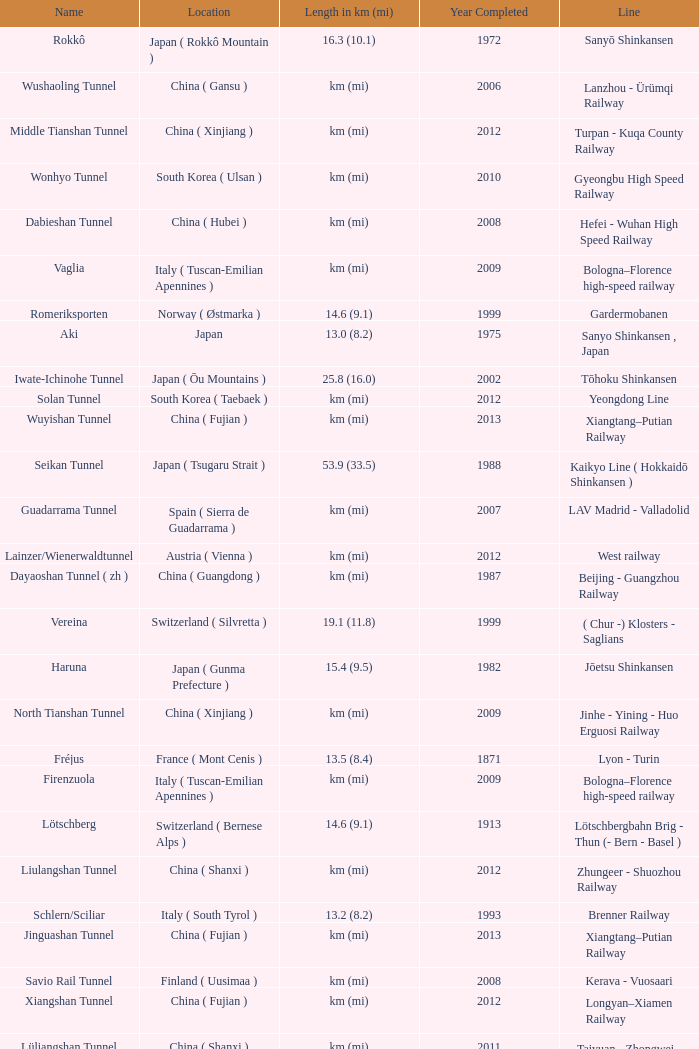Give me the full table as a dictionary. {'header': ['Name', 'Location', 'Length in km (mi)', 'Year Completed', 'Line'], 'rows': [['Rokkô', 'Japan ( Rokkô Mountain )', '16.3 (10.1)', '1972', 'Sanyō Shinkansen'], ['Wushaoling Tunnel', 'China ( Gansu )', 'km (mi)', '2006', 'Lanzhou - Ürümqi Railway'], ['Middle Tianshan Tunnel', 'China ( Xinjiang )', 'km (mi)', '2012', 'Turpan - Kuqa County Railway'], ['Wonhyo Tunnel', 'South Korea ( Ulsan )', 'km (mi)', '2010', 'Gyeongbu High Speed Railway'], ['Dabieshan Tunnel', 'China ( Hubei )', 'km (mi)', '2008', 'Hefei - Wuhan High Speed Railway'], ['Vaglia', 'Italy ( Tuscan-Emilian Apennines )', 'km (mi)', '2009', 'Bologna–Florence high-speed railway'], ['Romeriksporten', 'Norway ( Østmarka )', '14.6 (9.1)', '1999', 'Gardermobanen'], ['Aki', 'Japan', '13.0 (8.2)', '1975', 'Sanyo Shinkansen , Japan'], ['Iwate-Ichinohe Tunnel', 'Japan ( Ōu Mountains )', '25.8 (16.0)', '2002', 'Tōhoku Shinkansen'], ['Solan Tunnel', 'South Korea ( Taebaek )', 'km (mi)', '2012', 'Yeongdong Line'], ['Wuyishan Tunnel', 'China ( Fujian )', 'km (mi)', '2013', 'Xiangtang–Putian Railway'], ['Seikan Tunnel', 'Japan ( Tsugaru Strait )', '53.9 (33.5)', '1988', 'Kaikyo Line ( Hokkaidō Shinkansen )'], ['Guadarrama Tunnel', 'Spain ( Sierra de Guadarrama )', 'km (mi)', '2007', 'LAV Madrid - Valladolid'], ['Lainzer/Wienerwaldtunnel', 'Austria ( Vienna )', 'km (mi)', '2012', 'West railway'], ['Dayaoshan Tunnel ( zh )', 'China ( Guangdong )', 'km (mi)', '1987', 'Beijing - Guangzhou Railway'], ['Vereina', 'Switzerland ( Silvretta )', '19.1 (11.8)', '1999', '( Chur -) Klosters - Saglians'], ['Haruna', 'Japan ( Gunma Prefecture )', '15.4 (9.5)', '1982', 'Jōetsu Shinkansen'], ['North Tianshan Tunnel', 'China ( Xinjiang )', 'km (mi)', '2009', 'Jinhe - Yining - Huo Erguosi Railway'], ['Fréjus', 'France ( Mont Cenis )', '13.5 (8.4)', '1871', 'Lyon - Turin'], ['Firenzuola', 'Italy ( Tuscan-Emilian Apennines )', 'km (mi)', '2009', 'Bologna–Florence high-speed railway'], ['Lötschberg', 'Switzerland ( Bernese Alps )', '14.6 (9.1)', '1913', 'Lötschbergbahn Brig - Thun (- Bern - Basel )'], ['Liulangshan Tunnel', 'China ( Shanxi )', 'km (mi)', '2012', 'Zhungeer - Shuozhou Railway'], ['Schlern/Sciliar', 'Italy ( South Tyrol )', '13.2 (8.2)', '1993', 'Brenner Railway'], ['Jinguashan Tunnel', 'China ( Fujian )', 'km (mi)', '2013', 'Xiangtang–Putian Railway'], ['Savio Rail Tunnel', 'Finland ( Uusimaa )', 'km (mi)', '2008', 'Kerava - Vuosaari'], ['Xiangshan Tunnel', 'China ( Fujian )', 'km (mi)', '2012', 'Longyan–Xiamen Railway'], ['Lüliangshan Tunnel', 'China ( Shanxi )', 'km (mi)', '2011', 'Taiyuan - Zhongwei - Yinchuan Railway'], ['Apennine Base Tunnel', 'Italy ( Apennine Mountains )', '18.5 (11.5)', '1934', 'Bologna - Florence'], ['Gorigamine', 'Japan ( Akaishi Mountains )', '15.2 (9.4)', '1997', 'Nagano Shinkansen ( Hokuriku Shinkansen )'], ['Severomuyskiy', 'Russia ( Severomuysky Range )', '15.3 (9.5)', '2001', 'Baikal Amur Mainline'], ['Xuefengshan Tunnel', 'China ( Fujian )', 'km (mi)', '2013', 'Xiangtang–Putian Railway'], ['Monte Santomarco', 'Italy ( Sila Mountains )', '15.0 (9.3)', '1987', 'Paola - Cosenza'], ['Hakkōda Tunnel', 'Japan ( Hakkōda Mountains )', 'km (mi)', '2010', 'Tōhoku Shinkansen'], ['Qingyunshan Tunnel', 'China ( Fujian )', 'km (mi)', '2013', 'Xiangtang–Putian Railway'], ['Epping to Chatswood RailLink', 'Australia ( Sydney )', '13.5 (8.4)', '2009', 'Epping - Chatswood'], ['Gotthard Rail Tunnel', 'Switzerland ( Lepontine Alps )', '15.0 (9.3)', '1882', 'Gotthardbahn Luzern / Zürich - Lugano - Milano'], ['Daiyunshan Tunnel', 'China ( Fujian )', 'km (mi)', '2013', 'Xiangtang–Putian Railway'], ['Nakayama', 'Japan ( Nakayama Pass )', '14.9 (9.2)', '1982', 'Jōetsu Shinkansen'], ['Gaoganshan Tunnel', 'China ( Fujian )', 'km (mi)', '2013', 'Xiangtang–Putian Railway'], ['Lötschberg Base Tunnel', 'Switzerland ( Bernese Alps )', '34.5 (21.4)', '2007', 'Lötschbergbahn Brig - Thun (- Bern - Basel )'], ['Caponero-Capoverde', 'Italy', '13.1 (8.2)', '2001', 'Genova-Ventimiglia'], ['Simplon (2 tubes)', 'Italy / Switzerland ( Lepontine Alps )', '19.8 (12.3)', '1906/1922', 'Genève/Basel - Brig - Novara / Milano'], ['Daishimizu Tunnel', 'Japan ( Mount Tanigawa )', '22.2 (13.8)', '1982', 'Jōetsu Shinkansen'], ['El Sargento #4', 'Peru', 'km (mi)', '1975', 'Tacna - Moquegua'], ['Hex River', 'South Africa ( Hex River Pass )', 'km (mi)', '1989', 'Pretoria - Cape Town'], ['Furka Base', 'Switzerland ( Urner Alps )', '15.4 (9.6)', '1982', 'Andermatt - Brig'], ['Mount Macdonald Tunnel', 'Canada ( Rogers Pass )', '14.7 (9.1)', '1989', 'Calgary - Revelstoke'], ['Channel Tunnel', 'France / United Kingdom ( English Channel )', '50.5 (31.3)', '1994', 'Channel Tunnel'], ['Maotianshan Tunnel', 'China ( Shaanxi )', 'km (mi)', '2011', "Baotou - Xi'an Railway"], ['Shin-Shimizu Tunnel', 'Japan ( Mount Tanigawa )', '13.5 (8.4)', '1967', 'Jōetsu Line'], ['Marmaray', 'Turkey ( Istanbul )', 'km (mi)', '2013', 'Marmaray'], ['Geumjeong Tunnel', 'South Korea ( Busan )', 'km (mi)', '2010', 'Gyeongbu High Speed Railway'], ['Shin Kanmon', 'Japan ( Kanmon Straits )', '18.7 (11.6)', '1975', 'Sanyō Shinkansen'], ['Hokuriku', 'Japan ( Mount Kinome )', '13.9 (8.6)', '1962', 'Hokuriku Main Line'], ['Yesanguan Tunnel', 'China ( Hubei )', 'km (mi)', '2009', 'Yichang - Wanzhou Railway'], ['Guanshan Tunnel', 'China ( Gansu )', 'km (mi)', '2012', 'Tianshui - Pingliang Railway'], ['Qinling Tunnel ( zh )', 'China ( Shaanxi )', 'km (mi)', '2002/2005', "Xi'an–Ankang Railway"], ['Taihang Tunnel', 'China ( Shanxi )', 'km (mi)', '2007', 'Shijiazhuang–Taiyuan High-Speed Railway']]} Which line is the Geumjeong tunnel? Gyeongbu High Speed Railway. 